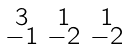Convert formula to latex. <formula><loc_0><loc_0><loc_500><loc_500>\begin{smallmatrix} 3 & 1 & 1 \\ - 1 & - 2 & - 2 \end{smallmatrix}</formula> 